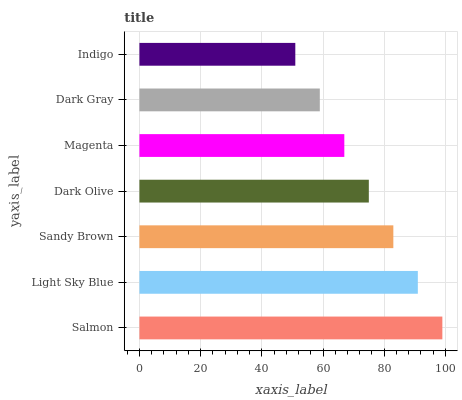Is Indigo the minimum?
Answer yes or no. Yes. Is Salmon the maximum?
Answer yes or no. Yes. Is Light Sky Blue the minimum?
Answer yes or no. No. Is Light Sky Blue the maximum?
Answer yes or no. No. Is Salmon greater than Light Sky Blue?
Answer yes or no. Yes. Is Light Sky Blue less than Salmon?
Answer yes or no. Yes. Is Light Sky Blue greater than Salmon?
Answer yes or no. No. Is Salmon less than Light Sky Blue?
Answer yes or no. No. Is Dark Olive the high median?
Answer yes or no. Yes. Is Dark Olive the low median?
Answer yes or no. Yes. Is Indigo the high median?
Answer yes or no. No. Is Magenta the low median?
Answer yes or no. No. 